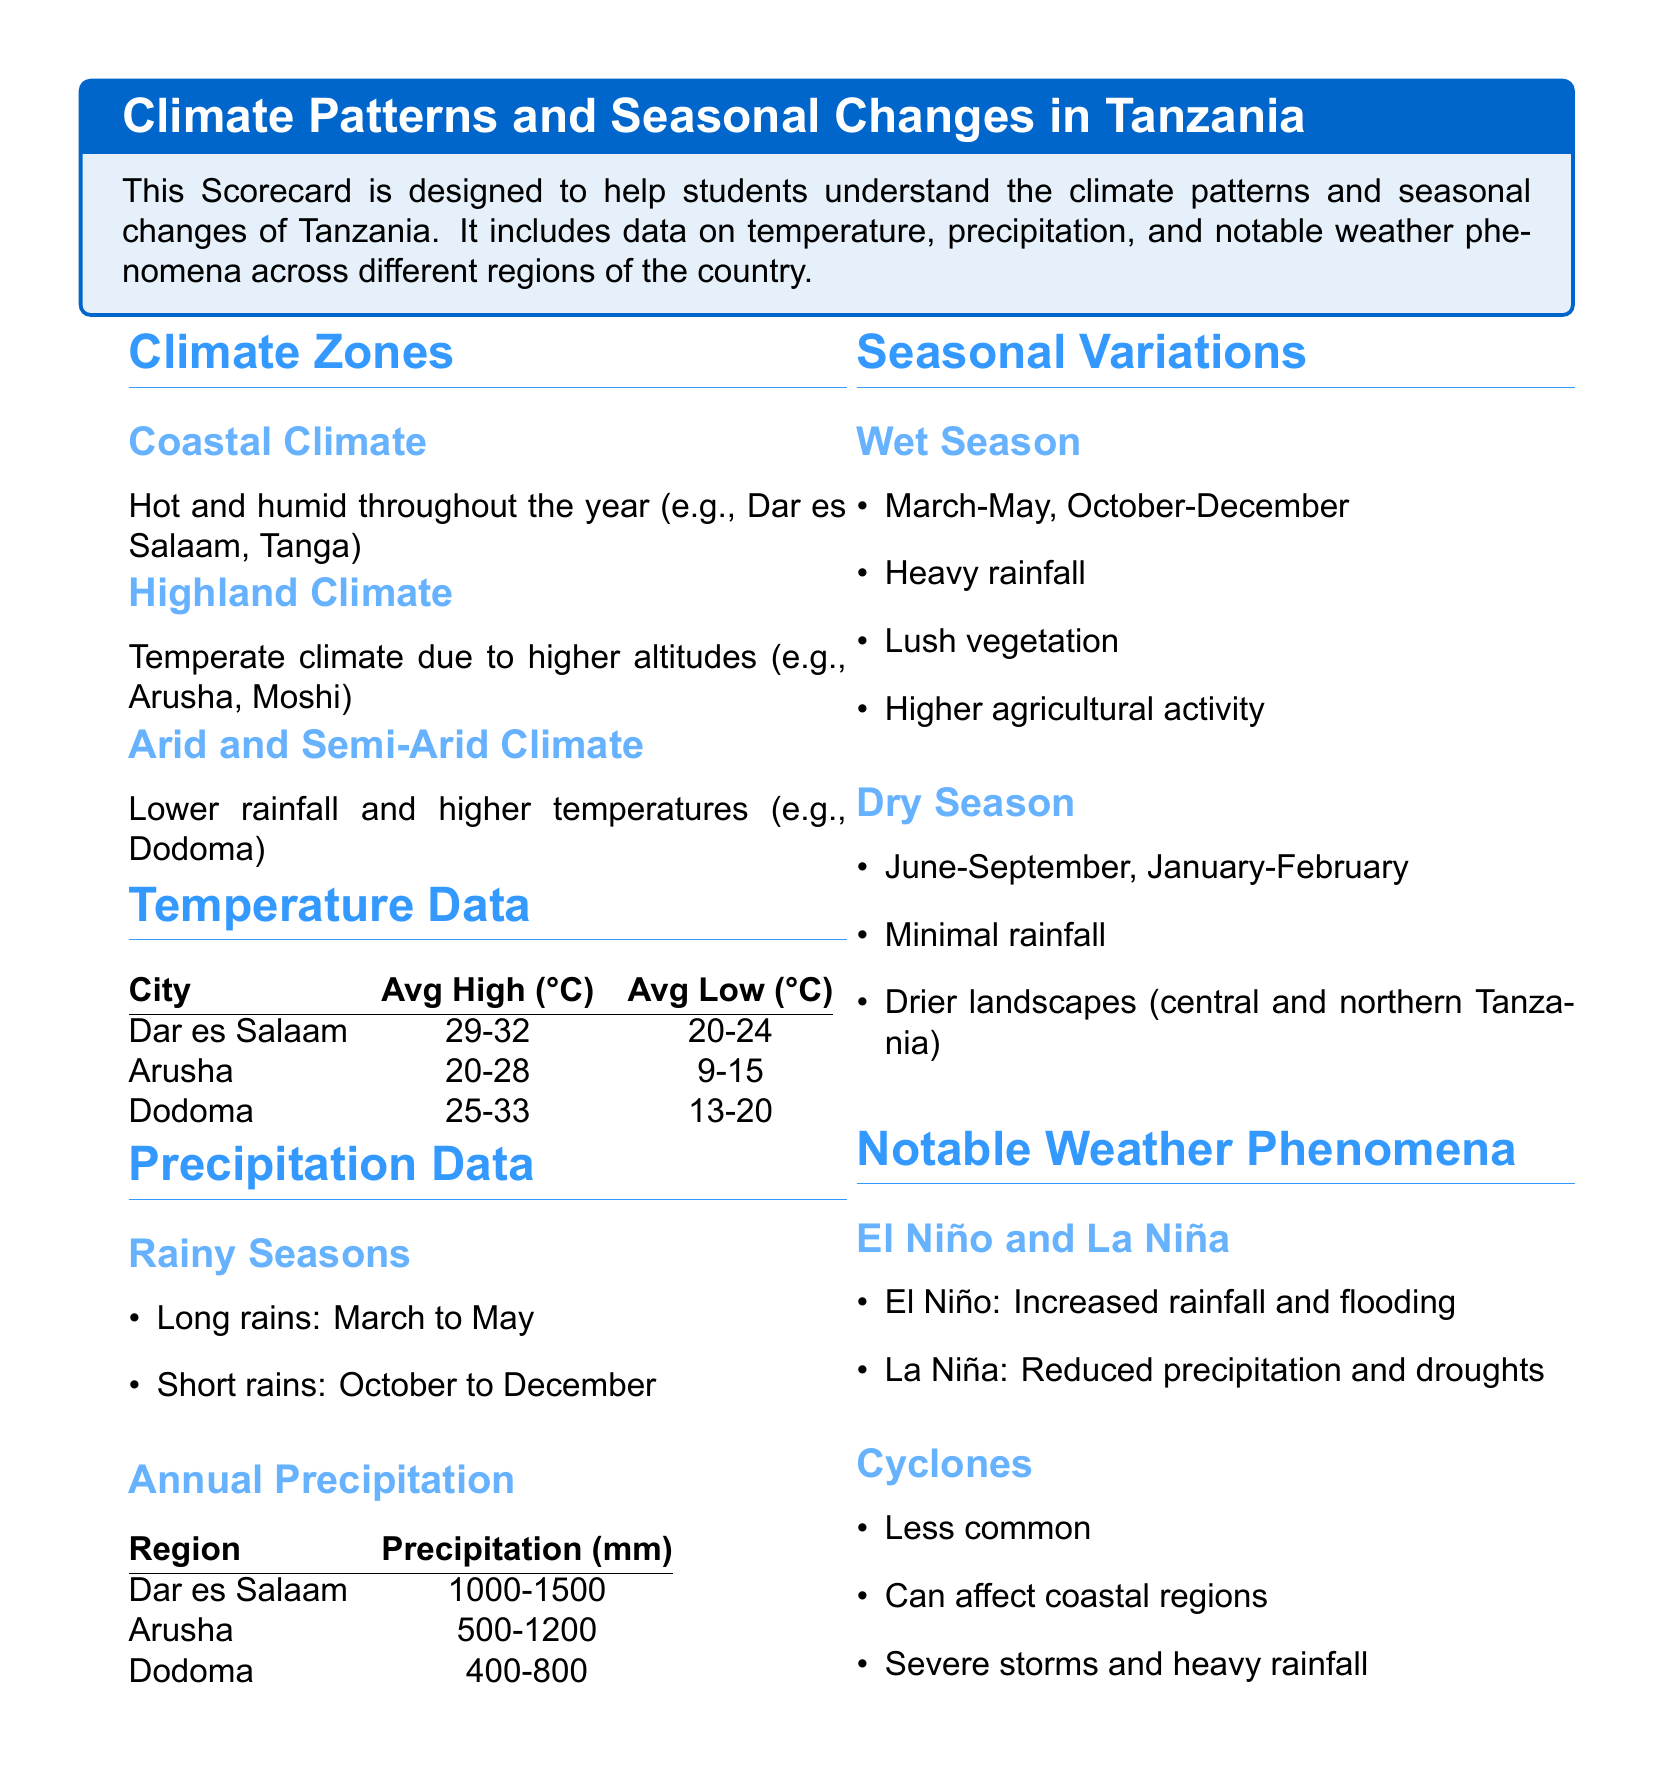What are the two rainy seasons in Tanzania? The document states that the rainy seasons in Tanzania are the long rains from March to May and the short rains from October to December.
Answer: March to May, October to December What is the average high temperature in Arusha? The average high temperature for Arusha is provided in the temperature data section of the document.
Answer: 20-28 What type of climate is found in Dodoma? The document describes Dodoma as having an arid and semi-arid climate.
Answer: Arid and Semi-Arid Climate What is the annual precipitation range for Dar es Salaam? The annual precipitation for Dar es Salaam is specified in the precipitation data table.
Answer: 1000-1500 What phenomenon is associated with increased rainfall in Tanzania? The document mentions that El Niño is associated with increased rainfall and flooding.
Answer: El Niño What months constitute the dry season in Tanzania? According to the seasonal variations section, the dry season runs from June to September and January to February.
Answer: June-September, January-February Which cities in Tanzania have a temperate climate? The document mentions Arusha and Moshi as examples of places with temperate climate due to higher altitudes.
Answer: Arusha, Moshi What type of weather event can affect coastal regions but is less common? The document states that cyclones can affect coastal regions, although they are less common.
Answer: Cyclones 